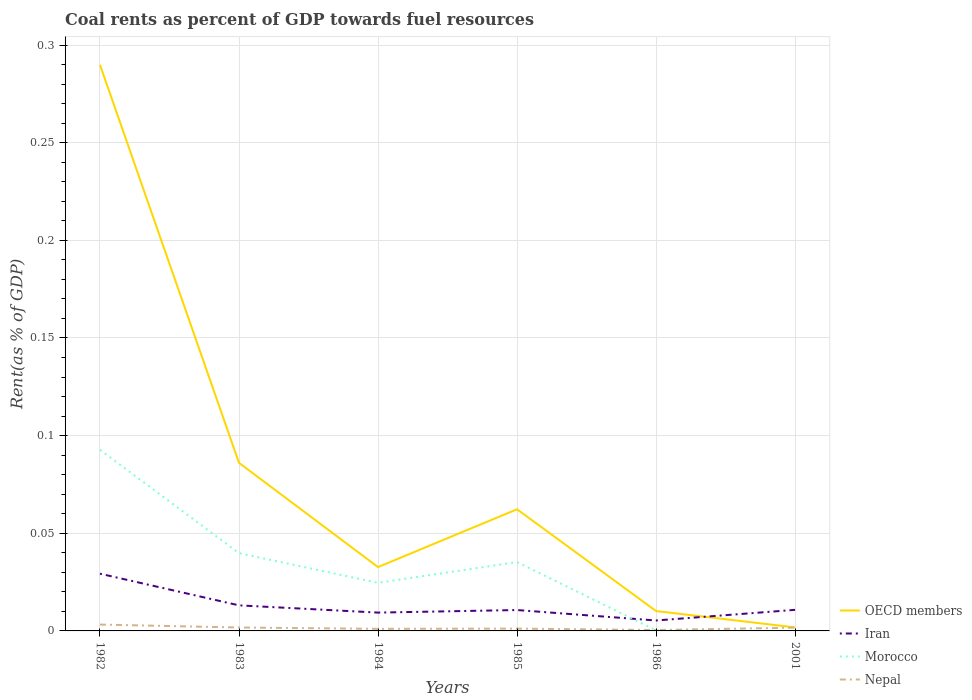How many different coloured lines are there?
Your answer should be compact. 4. Does the line corresponding to Morocco intersect with the line corresponding to OECD members?
Provide a short and direct response. No. Across all years, what is the maximum coal rent in Nepal?
Provide a short and direct response. 0. In which year was the coal rent in Iran maximum?
Provide a succinct answer. 1986. What is the total coal rent in Morocco in the graph?
Offer a terse response. 0.09. What is the difference between the highest and the second highest coal rent in Morocco?
Offer a terse response. 0.09. Is the coal rent in OECD members strictly greater than the coal rent in Nepal over the years?
Your answer should be very brief. No. What is the difference between two consecutive major ticks on the Y-axis?
Ensure brevity in your answer.  0.05. Does the graph contain grids?
Provide a short and direct response. Yes. Where does the legend appear in the graph?
Offer a terse response. Bottom right. What is the title of the graph?
Your response must be concise. Coal rents as percent of GDP towards fuel resources. What is the label or title of the X-axis?
Your response must be concise. Years. What is the label or title of the Y-axis?
Provide a succinct answer. Rent(as % of GDP). What is the Rent(as % of GDP) in OECD members in 1982?
Your answer should be compact. 0.29. What is the Rent(as % of GDP) of Iran in 1982?
Your answer should be compact. 0.03. What is the Rent(as % of GDP) in Morocco in 1982?
Your response must be concise. 0.09. What is the Rent(as % of GDP) in Nepal in 1982?
Your response must be concise. 0. What is the Rent(as % of GDP) of OECD members in 1983?
Your answer should be very brief. 0.09. What is the Rent(as % of GDP) in Iran in 1983?
Keep it short and to the point. 0.01. What is the Rent(as % of GDP) of Morocco in 1983?
Give a very brief answer. 0.04. What is the Rent(as % of GDP) of Nepal in 1983?
Your answer should be compact. 0. What is the Rent(as % of GDP) in OECD members in 1984?
Provide a succinct answer. 0.03. What is the Rent(as % of GDP) in Iran in 1984?
Ensure brevity in your answer.  0.01. What is the Rent(as % of GDP) in Morocco in 1984?
Keep it short and to the point. 0.02. What is the Rent(as % of GDP) of Nepal in 1984?
Offer a terse response. 0. What is the Rent(as % of GDP) in OECD members in 1985?
Offer a very short reply. 0.06. What is the Rent(as % of GDP) of Iran in 1985?
Provide a succinct answer. 0.01. What is the Rent(as % of GDP) in Morocco in 1985?
Provide a succinct answer. 0.04. What is the Rent(as % of GDP) of Nepal in 1985?
Your answer should be very brief. 0. What is the Rent(as % of GDP) in OECD members in 1986?
Your response must be concise. 0.01. What is the Rent(as % of GDP) of Iran in 1986?
Your answer should be very brief. 0.01. What is the Rent(as % of GDP) of Morocco in 1986?
Make the answer very short. 0. What is the Rent(as % of GDP) of Nepal in 1986?
Your answer should be compact. 0. What is the Rent(as % of GDP) in OECD members in 2001?
Ensure brevity in your answer.  0. What is the Rent(as % of GDP) of Iran in 2001?
Your response must be concise. 0.01. What is the Rent(as % of GDP) of Morocco in 2001?
Ensure brevity in your answer.  1.3061100764157e-7. What is the Rent(as % of GDP) of Nepal in 2001?
Keep it short and to the point. 0. Across all years, what is the maximum Rent(as % of GDP) in OECD members?
Provide a succinct answer. 0.29. Across all years, what is the maximum Rent(as % of GDP) in Iran?
Your answer should be compact. 0.03. Across all years, what is the maximum Rent(as % of GDP) of Morocco?
Offer a terse response. 0.09. Across all years, what is the maximum Rent(as % of GDP) of Nepal?
Make the answer very short. 0. Across all years, what is the minimum Rent(as % of GDP) of OECD members?
Give a very brief answer. 0. Across all years, what is the minimum Rent(as % of GDP) of Iran?
Provide a succinct answer. 0.01. Across all years, what is the minimum Rent(as % of GDP) of Morocco?
Provide a short and direct response. 1.3061100764157e-7. Across all years, what is the minimum Rent(as % of GDP) in Nepal?
Make the answer very short. 0. What is the total Rent(as % of GDP) of OECD members in the graph?
Make the answer very short. 0.48. What is the total Rent(as % of GDP) of Iran in the graph?
Provide a succinct answer. 0.08. What is the total Rent(as % of GDP) in Morocco in the graph?
Offer a terse response. 0.19. What is the total Rent(as % of GDP) in Nepal in the graph?
Make the answer very short. 0.01. What is the difference between the Rent(as % of GDP) of OECD members in 1982 and that in 1983?
Your response must be concise. 0.2. What is the difference between the Rent(as % of GDP) of Iran in 1982 and that in 1983?
Make the answer very short. 0.02. What is the difference between the Rent(as % of GDP) in Morocco in 1982 and that in 1983?
Give a very brief answer. 0.05. What is the difference between the Rent(as % of GDP) of Nepal in 1982 and that in 1983?
Offer a terse response. 0. What is the difference between the Rent(as % of GDP) of OECD members in 1982 and that in 1984?
Your answer should be compact. 0.26. What is the difference between the Rent(as % of GDP) in Iran in 1982 and that in 1984?
Provide a succinct answer. 0.02. What is the difference between the Rent(as % of GDP) of Morocco in 1982 and that in 1984?
Provide a short and direct response. 0.07. What is the difference between the Rent(as % of GDP) of Nepal in 1982 and that in 1984?
Give a very brief answer. 0. What is the difference between the Rent(as % of GDP) in OECD members in 1982 and that in 1985?
Ensure brevity in your answer.  0.23. What is the difference between the Rent(as % of GDP) in Iran in 1982 and that in 1985?
Make the answer very short. 0.02. What is the difference between the Rent(as % of GDP) of Morocco in 1982 and that in 1985?
Provide a succinct answer. 0.06. What is the difference between the Rent(as % of GDP) in Nepal in 1982 and that in 1985?
Give a very brief answer. 0. What is the difference between the Rent(as % of GDP) of OECD members in 1982 and that in 1986?
Keep it short and to the point. 0.28. What is the difference between the Rent(as % of GDP) in Iran in 1982 and that in 1986?
Make the answer very short. 0.02. What is the difference between the Rent(as % of GDP) in Morocco in 1982 and that in 1986?
Make the answer very short. 0.09. What is the difference between the Rent(as % of GDP) in Nepal in 1982 and that in 1986?
Keep it short and to the point. 0. What is the difference between the Rent(as % of GDP) of OECD members in 1982 and that in 2001?
Make the answer very short. 0.29. What is the difference between the Rent(as % of GDP) in Iran in 1982 and that in 2001?
Give a very brief answer. 0.02. What is the difference between the Rent(as % of GDP) in Morocco in 1982 and that in 2001?
Keep it short and to the point. 0.09. What is the difference between the Rent(as % of GDP) of Nepal in 1982 and that in 2001?
Provide a short and direct response. 0. What is the difference between the Rent(as % of GDP) of OECD members in 1983 and that in 1984?
Make the answer very short. 0.05. What is the difference between the Rent(as % of GDP) of Iran in 1983 and that in 1984?
Your answer should be compact. 0. What is the difference between the Rent(as % of GDP) in Morocco in 1983 and that in 1984?
Provide a succinct answer. 0.02. What is the difference between the Rent(as % of GDP) of Nepal in 1983 and that in 1984?
Provide a short and direct response. 0. What is the difference between the Rent(as % of GDP) in OECD members in 1983 and that in 1985?
Make the answer very short. 0.02. What is the difference between the Rent(as % of GDP) of Iran in 1983 and that in 1985?
Ensure brevity in your answer.  0. What is the difference between the Rent(as % of GDP) in Morocco in 1983 and that in 1985?
Keep it short and to the point. 0. What is the difference between the Rent(as % of GDP) in Nepal in 1983 and that in 1985?
Offer a terse response. 0. What is the difference between the Rent(as % of GDP) of OECD members in 1983 and that in 1986?
Give a very brief answer. 0.08. What is the difference between the Rent(as % of GDP) of Iran in 1983 and that in 1986?
Offer a terse response. 0.01. What is the difference between the Rent(as % of GDP) of Morocco in 1983 and that in 1986?
Keep it short and to the point. 0.04. What is the difference between the Rent(as % of GDP) of Nepal in 1983 and that in 1986?
Keep it short and to the point. 0. What is the difference between the Rent(as % of GDP) in OECD members in 1983 and that in 2001?
Offer a very short reply. 0.08. What is the difference between the Rent(as % of GDP) in Iran in 1983 and that in 2001?
Keep it short and to the point. 0. What is the difference between the Rent(as % of GDP) in Morocco in 1983 and that in 2001?
Offer a terse response. 0.04. What is the difference between the Rent(as % of GDP) of OECD members in 1984 and that in 1985?
Provide a succinct answer. -0.03. What is the difference between the Rent(as % of GDP) of Iran in 1984 and that in 1985?
Your answer should be very brief. -0. What is the difference between the Rent(as % of GDP) of Morocco in 1984 and that in 1985?
Offer a terse response. -0.01. What is the difference between the Rent(as % of GDP) in Nepal in 1984 and that in 1985?
Give a very brief answer. -0. What is the difference between the Rent(as % of GDP) of OECD members in 1984 and that in 1986?
Provide a succinct answer. 0.02. What is the difference between the Rent(as % of GDP) of Iran in 1984 and that in 1986?
Offer a very short reply. 0. What is the difference between the Rent(as % of GDP) of Morocco in 1984 and that in 1986?
Offer a terse response. 0.02. What is the difference between the Rent(as % of GDP) in Nepal in 1984 and that in 1986?
Provide a succinct answer. 0. What is the difference between the Rent(as % of GDP) in OECD members in 1984 and that in 2001?
Make the answer very short. 0.03. What is the difference between the Rent(as % of GDP) of Iran in 1984 and that in 2001?
Your response must be concise. -0. What is the difference between the Rent(as % of GDP) in Morocco in 1984 and that in 2001?
Offer a very short reply. 0.02. What is the difference between the Rent(as % of GDP) of Nepal in 1984 and that in 2001?
Your answer should be compact. -0. What is the difference between the Rent(as % of GDP) of OECD members in 1985 and that in 1986?
Keep it short and to the point. 0.05. What is the difference between the Rent(as % of GDP) of Iran in 1985 and that in 1986?
Your response must be concise. 0.01. What is the difference between the Rent(as % of GDP) of Morocco in 1985 and that in 1986?
Ensure brevity in your answer.  0.04. What is the difference between the Rent(as % of GDP) in Nepal in 1985 and that in 1986?
Provide a succinct answer. 0. What is the difference between the Rent(as % of GDP) of OECD members in 1985 and that in 2001?
Your response must be concise. 0.06. What is the difference between the Rent(as % of GDP) in Iran in 1985 and that in 2001?
Keep it short and to the point. -0. What is the difference between the Rent(as % of GDP) in Morocco in 1985 and that in 2001?
Make the answer very short. 0.04. What is the difference between the Rent(as % of GDP) in Nepal in 1985 and that in 2001?
Your response must be concise. -0. What is the difference between the Rent(as % of GDP) of OECD members in 1986 and that in 2001?
Provide a succinct answer. 0.01. What is the difference between the Rent(as % of GDP) in Iran in 1986 and that in 2001?
Your answer should be very brief. -0.01. What is the difference between the Rent(as % of GDP) in Morocco in 1986 and that in 2001?
Offer a very short reply. 0. What is the difference between the Rent(as % of GDP) in Nepal in 1986 and that in 2001?
Provide a succinct answer. -0. What is the difference between the Rent(as % of GDP) of OECD members in 1982 and the Rent(as % of GDP) of Iran in 1983?
Ensure brevity in your answer.  0.28. What is the difference between the Rent(as % of GDP) in OECD members in 1982 and the Rent(as % of GDP) in Morocco in 1983?
Offer a very short reply. 0.25. What is the difference between the Rent(as % of GDP) of OECD members in 1982 and the Rent(as % of GDP) of Nepal in 1983?
Your answer should be compact. 0.29. What is the difference between the Rent(as % of GDP) of Iran in 1982 and the Rent(as % of GDP) of Morocco in 1983?
Offer a terse response. -0.01. What is the difference between the Rent(as % of GDP) of Iran in 1982 and the Rent(as % of GDP) of Nepal in 1983?
Offer a very short reply. 0.03. What is the difference between the Rent(as % of GDP) of Morocco in 1982 and the Rent(as % of GDP) of Nepal in 1983?
Your answer should be compact. 0.09. What is the difference between the Rent(as % of GDP) in OECD members in 1982 and the Rent(as % of GDP) in Iran in 1984?
Ensure brevity in your answer.  0.28. What is the difference between the Rent(as % of GDP) in OECD members in 1982 and the Rent(as % of GDP) in Morocco in 1984?
Your answer should be compact. 0.27. What is the difference between the Rent(as % of GDP) of OECD members in 1982 and the Rent(as % of GDP) of Nepal in 1984?
Provide a succinct answer. 0.29. What is the difference between the Rent(as % of GDP) in Iran in 1982 and the Rent(as % of GDP) in Morocco in 1984?
Provide a succinct answer. 0. What is the difference between the Rent(as % of GDP) of Iran in 1982 and the Rent(as % of GDP) of Nepal in 1984?
Make the answer very short. 0.03. What is the difference between the Rent(as % of GDP) in Morocco in 1982 and the Rent(as % of GDP) in Nepal in 1984?
Ensure brevity in your answer.  0.09. What is the difference between the Rent(as % of GDP) in OECD members in 1982 and the Rent(as % of GDP) in Iran in 1985?
Ensure brevity in your answer.  0.28. What is the difference between the Rent(as % of GDP) in OECD members in 1982 and the Rent(as % of GDP) in Morocco in 1985?
Your answer should be compact. 0.25. What is the difference between the Rent(as % of GDP) in OECD members in 1982 and the Rent(as % of GDP) in Nepal in 1985?
Your answer should be very brief. 0.29. What is the difference between the Rent(as % of GDP) in Iran in 1982 and the Rent(as % of GDP) in Morocco in 1985?
Offer a terse response. -0.01. What is the difference between the Rent(as % of GDP) of Iran in 1982 and the Rent(as % of GDP) of Nepal in 1985?
Offer a terse response. 0.03. What is the difference between the Rent(as % of GDP) of Morocco in 1982 and the Rent(as % of GDP) of Nepal in 1985?
Offer a terse response. 0.09. What is the difference between the Rent(as % of GDP) of OECD members in 1982 and the Rent(as % of GDP) of Iran in 1986?
Your answer should be very brief. 0.28. What is the difference between the Rent(as % of GDP) of OECD members in 1982 and the Rent(as % of GDP) of Morocco in 1986?
Offer a very short reply. 0.29. What is the difference between the Rent(as % of GDP) in OECD members in 1982 and the Rent(as % of GDP) in Nepal in 1986?
Provide a succinct answer. 0.29. What is the difference between the Rent(as % of GDP) in Iran in 1982 and the Rent(as % of GDP) in Morocco in 1986?
Offer a very short reply. 0.03. What is the difference between the Rent(as % of GDP) of Iran in 1982 and the Rent(as % of GDP) of Nepal in 1986?
Your answer should be compact. 0.03. What is the difference between the Rent(as % of GDP) in Morocco in 1982 and the Rent(as % of GDP) in Nepal in 1986?
Provide a succinct answer. 0.09. What is the difference between the Rent(as % of GDP) of OECD members in 1982 and the Rent(as % of GDP) of Iran in 2001?
Keep it short and to the point. 0.28. What is the difference between the Rent(as % of GDP) in OECD members in 1982 and the Rent(as % of GDP) in Morocco in 2001?
Provide a succinct answer. 0.29. What is the difference between the Rent(as % of GDP) of OECD members in 1982 and the Rent(as % of GDP) of Nepal in 2001?
Ensure brevity in your answer.  0.29. What is the difference between the Rent(as % of GDP) in Iran in 1982 and the Rent(as % of GDP) in Morocco in 2001?
Your response must be concise. 0.03. What is the difference between the Rent(as % of GDP) of Iran in 1982 and the Rent(as % of GDP) of Nepal in 2001?
Your response must be concise. 0.03. What is the difference between the Rent(as % of GDP) in Morocco in 1982 and the Rent(as % of GDP) in Nepal in 2001?
Your answer should be very brief. 0.09. What is the difference between the Rent(as % of GDP) in OECD members in 1983 and the Rent(as % of GDP) in Iran in 1984?
Offer a terse response. 0.08. What is the difference between the Rent(as % of GDP) in OECD members in 1983 and the Rent(as % of GDP) in Morocco in 1984?
Ensure brevity in your answer.  0.06. What is the difference between the Rent(as % of GDP) in OECD members in 1983 and the Rent(as % of GDP) in Nepal in 1984?
Keep it short and to the point. 0.09. What is the difference between the Rent(as % of GDP) of Iran in 1983 and the Rent(as % of GDP) of Morocco in 1984?
Offer a very short reply. -0.01. What is the difference between the Rent(as % of GDP) in Iran in 1983 and the Rent(as % of GDP) in Nepal in 1984?
Your response must be concise. 0.01. What is the difference between the Rent(as % of GDP) in Morocco in 1983 and the Rent(as % of GDP) in Nepal in 1984?
Offer a very short reply. 0.04. What is the difference between the Rent(as % of GDP) of OECD members in 1983 and the Rent(as % of GDP) of Iran in 1985?
Offer a very short reply. 0.08. What is the difference between the Rent(as % of GDP) of OECD members in 1983 and the Rent(as % of GDP) of Morocco in 1985?
Your answer should be very brief. 0.05. What is the difference between the Rent(as % of GDP) in OECD members in 1983 and the Rent(as % of GDP) in Nepal in 1985?
Ensure brevity in your answer.  0.08. What is the difference between the Rent(as % of GDP) of Iran in 1983 and the Rent(as % of GDP) of Morocco in 1985?
Offer a terse response. -0.02. What is the difference between the Rent(as % of GDP) in Iran in 1983 and the Rent(as % of GDP) in Nepal in 1985?
Make the answer very short. 0.01. What is the difference between the Rent(as % of GDP) in Morocco in 1983 and the Rent(as % of GDP) in Nepal in 1985?
Give a very brief answer. 0.04. What is the difference between the Rent(as % of GDP) in OECD members in 1983 and the Rent(as % of GDP) in Iran in 1986?
Your answer should be very brief. 0.08. What is the difference between the Rent(as % of GDP) of OECD members in 1983 and the Rent(as % of GDP) of Morocco in 1986?
Provide a short and direct response. 0.09. What is the difference between the Rent(as % of GDP) of OECD members in 1983 and the Rent(as % of GDP) of Nepal in 1986?
Your answer should be very brief. 0.09. What is the difference between the Rent(as % of GDP) in Iran in 1983 and the Rent(as % of GDP) in Morocco in 1986?
Provide a succinct answer. 0.01. What is the difference between the Rent(as % of GDP) in Iran in 1983 and the Rent(as % of GDP) in Nepal in 1986?
Give a very brief answer. 0.01. What is the difference between the Rent(as % of GDP) in Morocco in 1983 and the Rent(as % of GDP) in Nepal in 1986?
Offer a very short reply. 0.04. What is the difference between the Rent(as % of GDP) of OECD members in 1983 and the Rent(as % of GDP) of Iran in 2001?
Give a very brief answer. 0.08. What is the difference between the Rent(as % of GDP) in OECD members in 1983 and the Rent(as % of GDP) in Morocco in 2001?
Keep it short and to the point. 0.09. What is the difference between the Rent(as % of GDP) of OECD members in 1983 and the Rent(as % of GDP) of Nepal in 2001?
Provide a short and direct response. 0.08. What is the difference between the Rent(as % of GDP) of Iran in 1983 and the Rent(as % of GDP) of Morocco in 2001?
Your response must be concise. 0.01. What is the difference between the Rent(as % of GDP) of Iran in 1983 and the Rent(as % of GDP) of Nepal in 2001?
Your response must be concise. 0.01. What is the difference between the Rent(as % of GDP) in Morocco in 1983 and the Rent(as % of GDP) in Nepal in 2001?
Offer a very short reply. 0.04. What is the difference between the Rent(as % of GDP) of OECD members in 1984 and the Rent(as % of GDP) of Iran in 1985?
Offer a terse response. 0.02. What is the difference between the Rent(as % of GDP) in OECD members in 1984 and the Rent(as % of GDP) in Morocco in 1985?
Provide a short and direct response. -0. What is the difference between the Rent(as % of GDP) in OECD members in 1984 and the Rent(as % of GDP) in Nepal in 1985?
Give a very brief answer. 0.03. What is the difference between the Rent(as % of GDP) in Iran in 1984 and the Rent(as % of GDP) in Morocco in 1985?
Keep it short and to the point. -0.03. What is the difference between the Rent(as % of GDP) in Iran in 1984 and the Rent(as % of GDP) in Nepal in 1985?
Ensure brevity in your answer.  0.01. What is the difference between the Rent(as % of GDP) in Morocco in 1984 and the Rent(as % of GDP) in Nepal in 1985?
Your response must be concise. 0.02. What is the difference between the Rent(as % of GDP) of OECD members in 1984 and the Rent(as % of GDP) of Iran in 1986?
Provide a short and direct response. 0.03. What is the difference between the Rent(as % of GDP) of OECD members in 1984 and the Rent(as % of GDP) of Morocco in 1986?
Keep it short and to the point. 0.03. What is the difference between the Rent(as % of GDP) in OECD members in 1984 and the Rent(as % of GDP) in Nepal in 1986?
Provide a succinct answer. 0.03. What is the difference between the Rent(as % of GDP) of Iran in 1984 and the Rent(as % of GDP) of Morocco in 1986?
Make the answer very short. 0.01. What is the difference between the Rent(as % of GDP) of Iran in 1984 and the Rent(as % of GDP) of Nepal in 1986?
Ensure brevity in your answer.  0.01. What is the difference between the Rent(as % of GDP) in Morocco in 1984 and the Rent(as % of GDP) in Nepal in 1986?
Your response must be concise. 0.02. What is the difference between the Rent(as % of GDP) in OECD members in 1984 and the Rent(as % of GDP) in Iran in 2001?
Your response must be concise. 0.02. What is the difference between the Rent(as % of GDP) in OECD members in 1984 and the Rent(as % of GDP) in Morocco in 2001?
Your answer should be very brief. 0.03. What is the difference between the Rent(as % of GDP) of OECD members in 1984 and the Rent(as % of GDP) of Nepal in 2001?
Offer a terse response. 0.03. What is the difference between the Rent(as % of GDP) in Iran in 1984 and the Rent(as % of GDP) in Morocco in 2001?
Your answer should be compact. 0.01. What is the difference between the Rent(as % of GDP) of Iran in 1984 and the Rent(as % of GDP) of Nepal in 2001?
Ensure brevity in your answer.  0.01. What is the difference between the Rent(as % of GDP) in Morocco in 1984 and the Rent(as % of GDP) in Nepal in 2001?
Provide a short and direct response. 0.02. What is the difference between the Rent(as % of GDP) of OECD members in 1985 and the Rent(as % of GDP) of Iran in 1986?
Provide a short and direct response. 0.06. What is the difference between the Rent(as % of GDP) of OECD members in 1985 and the Rent(as % of GDP) of Morocco in 1986?
Ensure brevity in your answer.  0.06. What is the difference between the Rent(as % of GDP) in OECD members in 1985 and the Rent(as % of GDP) in Nepal in 1986?
Provide a succinct answer. 0.06. What is the difference between the Rent(as % of GDP) of Iran in 1985 and the Rent(as % of GDP) of Morocco in 1986?
Offer a very short reply. 0.01. What is the difference between the Rent(as % of GDP) in Iran in 1985 and the Rent(as % of GDP) in Nepal in 1986?
Keep it short and to the point. 0.01. What is the difference between the Rent(as % of GDP) in Morocco in 1985 and the Rent(as % of GDP) in Nepal in 1986?
Give a very brief answer. 0.03. What is the difference between the Rent(as % of GDP) in OECD members in 1985 and the Rent(as % of GDP) in Iran in 2001?
Offer a very short reply. 0.05. What is the difference between the Rent(as % of GDP) in OECD members in 1985 and the Rent(as % of GDP) in Morocco in 2001?
Make the answer very short. 0.06. What is the difference between the Rent(as % of GDP) of OECD members in 1985 and the Rent(as % of GDP) of Nepal in 2001?
Offer a terse response. 0.06. What is the difference between the Rent(as % of GDP) of Iran in 1985 and the Rent(as % of GDP) of Morocco in 2001?
Provide a short and direct response. 0.01. What is the difference between the Rent(as % of GDP) of Iran in 1985 and the Rent(as % of GDP) of Nepal in 2001?
Ensure brevity in your answer.  0.01. What is the difference between the Rent(as % of GDP) of Morocco in 1985 and the Rent(as % of GDP) of Nepal in 2001?
Provide a succinct answer. 0.03. What is the difference between the Rent(as % of GDP) in OECD members in 1986 and the Rent(as % of GDP) in Iran in 2001?
Give a very brief answer. -0. What is the difference between the Rent(as % of GDP) of OECD members in 1986 and the Rent(as % of GDP) of Morocco in 2001?
Provide a short and direct response. 0.01. What is the difference between the Rent(as % of GDP) of OECD members in 1986 and the Rent(as % of GDP) of Nepal in 2001?
Keep it short and to the point. 0.01. What is the difference between the Rent(as % of GDP) in Iran in 1986 and the Rent(as % of GDP) in Morocco in 2001?
Your answer should be compact. 0.01. What is the difference between the Rent(as % of GDP) of Iran in 1986 and the Rent(as % of GDP) of Nepal in 2001?
Keep it short and to the point. 0. What is the difference between the Rent(as % of GDP) of Morocco in 1986 and the Rent(as % of GDP) of Nepal in 2001?
Provide a short and direct response. -0. What is the average Rent(as % of GDP) of OECD members per year?
Your answer should be compact. 0.08. What is the average Rent(as % of GDP) in Iran per year?
Your response must be concise. 0.01. What is the average Rent(as % of GDP) of Morocco per year?
Make the answer very short. 0.03. What is the average Rent(as % of GDP) of Nepal per year?
Provide a succinct answer. 0. In the year 1982, what is the difference between the Rent(as % of GDP) of OECD members and Rent(as % of GDP) of Iran?
Provide a short and direct response. 0.26. In the year 1982, what is the difference between the Rent(as % of GDP) in OECD members and Rent(as % of GDP) in Morocco?
Your response must be concise. 0.2. In the year 1982, what is the difference between the Rent(as % of GDP) in OECD members and Rent(as % of GDP) in Nepal?
Keep it short and to the point. 0.29. In the year 1982, what is the difference between the Rent(as % of GDP) of Iran and Rent(as % of GDP) of Morocco?
Keep it short and to the point. -0.06. In the year 1982, what is the difference between the Rent(as % of GDP) in Iran and Rent(as % of GDP) in Nepal?
Provide a short and direct response. 0.03. In the year 1982, what is the difference between the Rent(as % of GDP) of Morocco and Rent(as % of GDP) of Nepal?
Your response must be concise. 0.09. In the year 1983, what is the difference between the Rent(as % of GDP) in OECD members and Rent(as % of GDP) in Iran?
Offer a very short reply. 0.07. In the year 1983, what is the difference between the Rent(as % of GDP) in OECD members and Rent(as % of GDP) in Morocco?
Keep it short and to the point. 0.05. In the year 1983, what is the difference between the Rent(as % of GDP) of OECD members and Rent(as % of GDP) of Nepal?
Provide a short and direct response. 0.08. In the year 1983, what is the difference between the Rent(as % of GDP) in Iran and Rent(as % of GDP) in Morocco?
Ensure brevity in your answer.  -0.03. In the year 1983, what is the difference between the Rent(as % of GDP) of Iran and Rent(as % of GDP) of Nepal?
Provide a succinct answer. 0.01. In the year 1983, what is the difference between the Rent(as % of GDP) of Morocco and Rent(as % of GDP) of Nepal?
Give a very brief answer. 0.04. In the year 1984, what is the difference between the Rent(as % of GDP) in OECD members and Rent(as % of GDP) in Iran?
Keep it short and to the point. 0.02. In the year 1984, what is the difference between the Rent(as % of GDP) of OECD members and Rent(as % of GDP) of Morocco?
Offer a very short reply. 0.01. In the year 1984, what is the difference between the Rent(as % of GDP) of OECD members and Rent(as % of GDP) of Nepal?
Offer a terse response. 0.03. In the year 1984, what is the difference between the Rent(as % of GDP) in Iran and Rent(as % of GDP) in Morocco?
Offer a terse response. -0.02. In the year 1984, what is the difference between the Rent(as % of GDP) of Iran and Rent(as % of GDP) of Nepal?
Your response must be concise. 0.01. In the year 1984, what is the difference between the Rent(as % of GDP) of Morocco and Rent(as % of GDP) of Nepal?
Provide a short and direct response. 0.02. In the year 1985, what is the difference between the Rent(as % of GDP) of OECD members and Rent(as % of GDP) of Iran?
Keep it short and to the point. 0.05. In the year 1985, what is the difference between the Rent(as % of GDP) in OECD members and Rent(as % of GDP) in Morocco?
Offer a very short reply. 0.03. In the year 1985, what is the difference between the Rent(as % of GDP) of OECD members and Rent(as % of GDP) of Nepal?
Your answer should be very brief. 0.06. In the year 1985, what is the difference between the Rent(as % of GDP) in Iran and Rent(as % of GDP) in Morocco?
Your response must be concise. -0.02. In the year 1985, what is the difference between the Rent(as % of GDP) in Iran and Rent(as % of GDP) in Nepal?
Keep it short and to the point. 0.01. In the year 1985, what is the difference between the Rent(as % of GDP) in Morocco and Rent(as % of GDP) in Nepal?
Provide a succinct answer. 0.03. In the year 1986, what is the difference between the Rent(as % of GDP) of OECD members and Rent(as % of GDP) of Iran?
Your answer should be very brief. 0. In the year 1986, what is the difference between the Rent(as % of GDP) in OECD members and Rent(as % of GDP) in Morocco?
Offer a very short reply. 0.01. In the year 1986, what is the difference between the Rent(as % of GDP) in OECD members and Rent(as % of GDP) in Nepal?
Provide a short and direct response. 0.01. In the year 1986, what is the difference between the Rent(as % of GDP) in Iran and Rent(as % of GDP) in Morocco?
Make the answer very short. 0.01. In the year 1986, what is the difference between the Rent(as % of GDP) in Iran and Rent(as % of GDP) in Nepal?
Keep it short and to the point. 0. In the year 1986, what is the difference between the Rent(as % of GDP) in Morocco and Rent(as % of GDP) in Nepal?
Make the answer very short. -0. In the year 2001, what is the difference between the Rent(as % of GDP) in OECD members and Rent(as % of GDP) in Iran?
Make the answer very short. -0.01. In the year 2001, what is the difference between the Rent(as % of GDP) in OECD members and Rent(as % of GDP) in Morocco?
Provide a succinct answer. 0. In the year 2001, what is the difference between the Rent(as % of GDP) of Iran and Rent(as % of GDP) of Morocco?
Provide a short and direct response. 0.01. In the year 2001, what is the difference between the Rent(as % of GDP) of Iran and Rent(as % of GDP) of Nepal?
Provide a short and direct response. 0.01. In the year 2001, what is the difference between the Rent(as % of GDP) of Morocco and Rent(as % of GDP) of Nepal?
Make the answer very short. -0. What is the ratio of the Rent(as % of GDP) in OECD members in 1982 to that in 1983?
Provide a short and direct response. 3.37. What is the ratio of the Rent(as % of GDP) of Iran in 1982 to that in 1983?
Your answer should be very brief. 2.24. What is the ratio of the Rent(as % of GDP) in Morocco in 1982 to that in 1983?
Your answer should be very brief. 2.33. What is the ratio of the Rent(as % of GDP) in Nepal in 1982 to that in 1983?
Your response must be concise. 1.86. What is the ratio of the Rent(as % of GDP) in OECD members in 1982 to that in 1984?
Provide a succinct answer. 8.87. What is the ratio of the Rent(as % of GDP) of Iran in 1982 to that in 1984?
Give a very brief answer. 3.12. What is the ratio of the Rent(as % of GDP) in Morocco in 1982 to that in 1984?
Offer a terse response. 3.77. What is the ratio of the Rent(as % of GDP) of Nepal in 1982 to that in 1984?
Offer a terse response. 3.04. What is the ratio of the Rent(as % of GDP) of OECD members in 1982 to that in 1985?
Offer a terse response. 4.65. What is the ratio of the Rent(as % of GDP) of Iran in 1982 to that in 1985?
Provide a short and direct response. 2.74. What is the ratio of the Rent(as % of GDP) in Morocco in 1982 to that in 1985?
Ensure brevity in your answer.  2.63. What is the ratio of the Rent(as % of GDP) in Nepal in 1982 to that in 1985?
Give a very brief answer. 2.74. What is the ratio of the Rent(as % of GDP) of OECD members in 1982 to that in 1986?
Ensure brevity in your answer.  28.47. What is the ratio of the Rent(as % of GDP) of Iran in 1982 to that in 1986?
Give a very brief answer. 5.49. What is the ratio of the Rent(as % of GDP) in Morocco in 1982 to that in 1986?
Provide a short and direct response. 340.51. What is the ratio of the Rent(as % of GDP) in Nepal in 1982 to that in 1986?
Offer a very short reply. 6.93. What is the ratio of the Rent(as % of GDP) in OECD members in 1982 to that in 2001?
Give a very brief answer. 161.42. What is the ratio of the Rent(as % of GDP) of Iran in 1982 to that in 2001?
Provide a short and direct response. 2.71. What is the ratio of the Rent(as % of GDP) in Morocco in 1982 to that in 2001?
Provide a succinct answer. 7.10e+05. What is the ratio of the Rent(as % of GDP) in Nepal in 1982 to that in 2001?
Provide a short and direct response. 1.94. What is the ratio of the Rent(as % of GDP) of OECD members in 1983 to that in 1984?
Give a very brief answer. 2.63. What is the ratio of the Rent(as % of GDP) in Iran in 1983 to that in 1984?
Your answer should be very brief. 1.4. What is the ratio of the Rent(as % of GDP) of Morocco in 1983 to that in 1984?
Provide a succinct answer. 1.62. What is the ratio of the Rent(as % of GDP) in Nepal in 1983 to that in 1984?
Your response must be concise. 1.63. What is the ratio of the Rent(as % of GDP) of OECD members in 1983 to that in 1985?
Provide a succinct answer. 1.38. What is the ratio of the Rent(as % of GDP) in Iran in 1983 to that in 1985?
Offer a very short reply. 1.22. What is the ratio of the Rent(as % of GDP) of Morocco in 1983 to that in 1985?
Give a very brief answer. 1.13. What is the ratio of the Rent(as % of GDP) of Nepal in 1983 to that in 1985?
Provide a succinct answer. 1.47. What is the ratio of the Rent(as % of GDP) in OECD members in 1983 to that in 1986?
Give a very brief answer. 8.45. What is the ratio of the Rent(as % of GDP) of Iran in 1983 to that in 1986?
Ensure brevity in your answer.  2.45. What is the ratio of the Rent(as % of GDP) of Morocco in 1983 to that in 1986?
Provide a short and direct response. 146.16. What is the ratio of the Rent(as % of GDP) of Nepal in 1983 to that in 1986?
Make the answer very short. 3.72. What is the ratio of the Rent(as % of GDP) of OECD members in 1983 to that in 2001?
Your answer should be compact. 47.93. What is the ratio of the Rent(as % of GDP) of Iran in 1983 to that in 2001?
Ensure brevity in your answer.  1.21. What is the ratio of the Rent(as % of GDP) of Morocco in 1983 to that in 2001?
Offer a terse response. 3.05e+05. What is the ratio of the Rent(as % of GDP) in Nepal in 1983 to that in 2001?
Offer a terse response. 1.04. What is the ratio of the Rent(as % of GDP) of OECD members in 1984 to that in 1985?
Provide a succinct answer. 0.52. What is the ratio of the Rent(as % of GDP) of Iran in 1984 to that in 1985?
Make the answer very short. 0.88. What is the ratio of the Rent(as % of GDP) of Morocco in 1984 to that in 1985?
Your answer should be very brief. 0.7. What is the ratio of the Rent(as % of GDP) in Nepal in 1984 to that in 1985?
Your response must be concise. 0.9. What is the ratio of the Rent(as % of GDP) in OECD members in 1984 to that in 1986?
Keep it short and to the point. 3.21. What is the ratio of the Rent(as % of GDP) in Iran in 1984 to that in 1986?
Give a very brief answer. 1.76. What is the ratio of the Rent(as % of GDP) in Morocco in 1984 to that in 1986?
Provide a succinct answer. 90.4. What is the ratio of the Rent(as % of GDP) in Nepal in 1984 to that in 1986?
Your answer should be very brief. 2.28. What is the ratio of the Rent(as % of GDP) in OECD members in 1984 to that in 2001?
Give a very brief answer. 18.2. What is the ratio of the Rent(as % of GDP) in Iran in 1984 to that in 2001?
Make the answer very short. 0.87. What is the ratio of the Rent(as % of GDP) of Morocco in 1984 to that in 2001?
Provide a short and direct response. 1.89e+05. What is the ratio of the Rent(as % of GDP) in Nepal in 1984 to that in 2001?
Provide a short and direct response. 0.64. What is the ratio of the Rent(as % of GDP) of OECD members in 1985 to that in 1986?
Keep it short and to the point. 6.12. What is the ratio of the Rent(as % of GDP) in Iran in 1985 to that in 1986?
Your response must be concise. 2. What is the ratio of the Rent(as % of GDP) in Morocco in 1985 to that in 1986?
Offer a very short reply. 129.46. What is the ratio of the Rent(as % of GDP) of Nepal in 1985 to that in 1986?
Your answer should be very brief. 2.53. What is the ratio of the Rent(as % of GDP) in OECD members in 1985 to that in 2001?
Ensure brevity in your answer.  34.69. What is the ratio of the Rent(as % of GDP) in Morocco in 1985 to that in 2001?
Ensure brevity in your answer.  2.70e+05. What is the ratio of the Rent(as % of GDP) of Nepal in 1985 to that in 2001?
Keep it short and to the point. 0.71. What is the ratio of the Rent(as % of GDP) in OECD members in 1986 to that in 2001?
Offer a terse response. 5.67. What is the ratio of the Rent(as % of GDP) in Iran in 1986 to that in 2001?
Keep it short and to the point. 0.49. What is the ratio of the Rent(as % of GDP) in Morocco in 1986 to that in 2001?
Ensure brevity in your answer.  2085.71. What is the ratio of the Rent(as % of GDP) of Nepal in 1986 to that in 2001?
Ensure brevity in your answer.  0.28. What is the difference between the highest and the second highest Rent(as % of GDP) in OECD members?
Offer a very short reply. 0.2. What is the difference between the highest and the second highest Rent(as % of GDP) in Iran?
Offer a very short reply. 0.02. What is the difference between the highest and the second highest Rent(as % of GDP) in Morocco?
Your response must be concise. 0.05. What is the difference between the highest and the second highest Rent(as % of GDP) in Nepal?
Your response must be concise. 0. What is the difference between the highest and the lowest Rent(as % of GDP) of OECD members?
Your response must be concise. 0.29. What is the difference between the highest and the lowest Rent(as % of GDP) of Iran?
Offer a terse response. 0.02. What is the difference between the highest and the lowest Rent(as % of GDP) of Morocco?
Give a very brief answer. 0.09. What is the difference between the highest and the lowest Rent(as % of GDP) in Nepal?
Offer a very short reply. 0. 